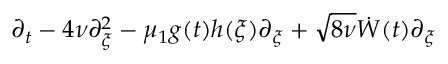<formula> <loc_0><loc_0><loc_500><loc_500>\partial _ { t } - 4 \nu \partial _ { \xi } ^ { 2 } - \mu _ { 1 } g ( t ) h ( \xi ) \partial _ { \xi } + \sqrt { 8 \nu } \dot { W } ( t ) \partial _ { \xi }</formula> 